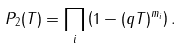Convert formula to latex. <formula><loc_0><loc_0><loc_500><loc_500>P _ { 2 } ( T ) = \prod _ { i } \left ( 1 - ( q T ) ^ { m _ { i } } \right ) .</formula> 